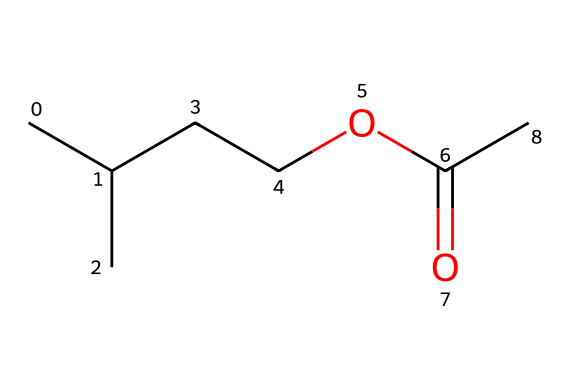What is the total number of carbon atoms in isoamyl acetate? In the SMILES representation, each "C" represents a carbon atom. By counting, there are 5 carbon atoms in the chain (CC(C)CC) and 1 more carbon in the ester group (C(=O)), making a total of 6 carbon atoms.
Answer: 6 How many oxygen atoms are present in this chemical? The SMILES representation contains "O" which represents oxygen. In isoamyl acetate, there are 2 oxygen atoms: one in the ester linkage and one in the carbonyl group (C(=O)).
Answer: 2 What type of functional group does isoamyl acetate belong to? The chemical has a characteristic ester functional group (–COOC). The presence of the carbonyl group (C(=O)) followed by an ether-like structure (–O–) indicates it is an ester.
Answer: ester Which atom in isoamyl acetate is part of the carbonyl group? In the structure, the "=" bond to "O" directly attached to the "C" indicates it’s the carbonyl carbon. This is identified as the carbon connected to the oxygen with a double bond.
Answer: carbon What is the primary reason isoamyl acetate has a banana scent? The structure contains a branched alkyl group and a specific ester functional group that is characteristic of compounds known to produce fruity aromas. The specific arrangement contributes to its unique smell, recognized as banana-like.
Answer: ester structure How many hydrogen bonds can isoamyl acetate form? As an ester, isoamyl acetate does not have active hydrogen bonds (like N-H or O-H), which are responsible for hydrogen bonding. However, it can participate in dipole-dipole interactions due to its polar nature. Therefore, it doesn't have hydrogen bonds to form.
Answer: 0 